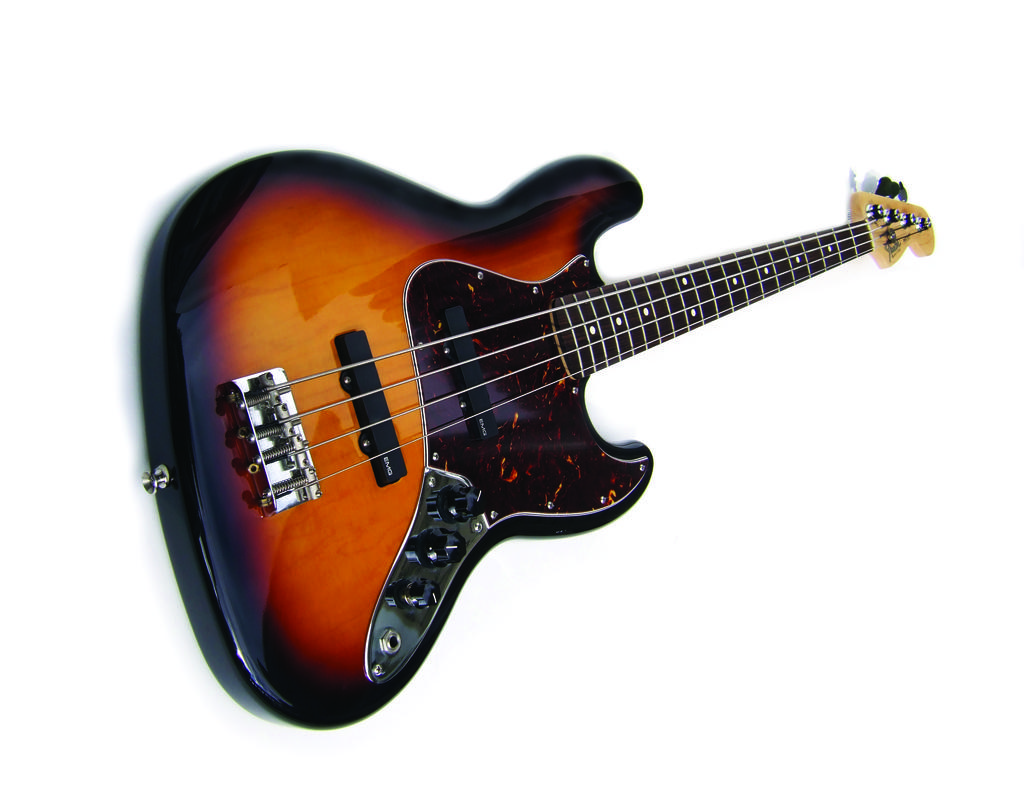What musical instrument is present in the image? There is a guitar in the image. What are the guitar's main components? The guitar has strings and tuners. How does the guitar use its wrist to play music in the image? The guitar does not have a wrist, as it is an inanimate object. The guitar's strings are played by a person using their fingers or a pick. 